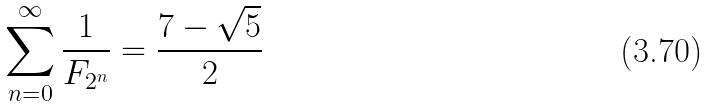<formula> <loc_0><loc_0><loc_500><loc_500>\sum _ { n = 0 } ^ { \infty } \frac { 1 } { F _ { 2 ^ { n } } } = \frac { 7 - \sqrt { 5 } } { 2 }</formula> 